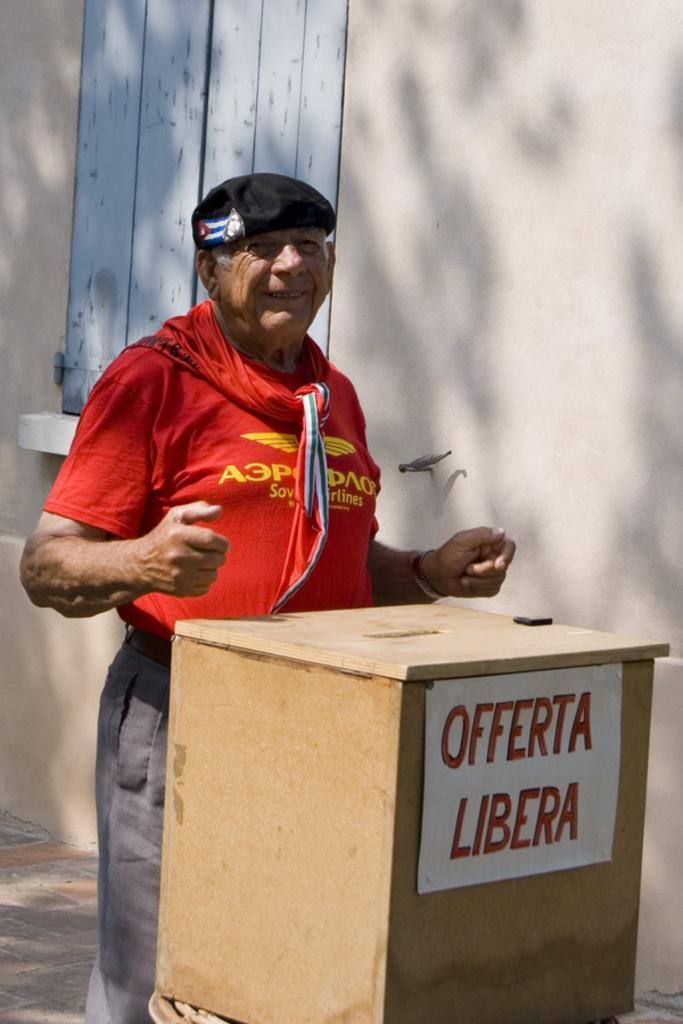Who is the main subject in the image? There is a person in the center of the image. What is the person wearing on their upper body? The person is wearing a red t-shirt. What type of headwear is the person wearing? The person is wearing a black cap. What can be seen near the person in the image? The person is standing near a podium. What is visible in the background of the image? There is a wall and a window in the background of the image. What type of loaf is being sliced on the table in the image? There is no table or loaf present in the image; it features a person standing near a podium with a wall and window in the background. 